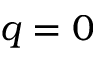Convert formula to latex. <formula><loc_0><loc_0><loc_500><loc_500>q = 0</formula> 